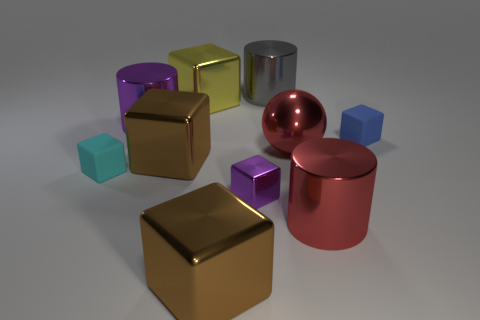Subtract 4 cubes. How many cubes are left? 2 Subtract all large yellow shiny blocks. How many blocks are left? 5 Subtract all blue blocks. How many blocks are left? 5 Subtract all blue blocks. Subtract all blue cylinders. How many blocks are left? 5 Subtract all cubes. How many objects are left? 4 Subtract all big red cylinders. Subtract all shiny cubes. How many objects are left? 5 Add 4 tiny things. How many tiny things are left? 7 Add 3 large brown cubes. How many large brown cubes exist? 5 Subtract 0 brown cylinders. How many objects are left? 10 